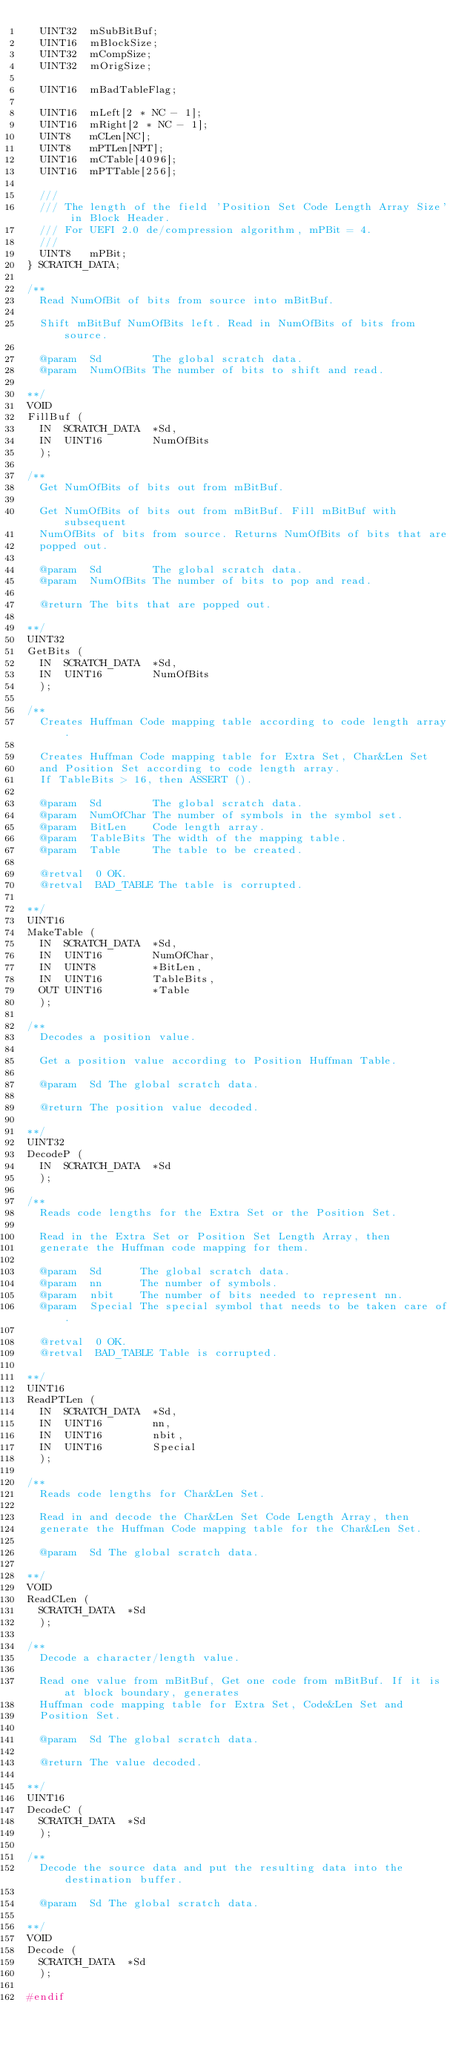<code> <loc_0><loc_0><loc_500><loc_500><_C_>  UINT32  mSubBitBuf;
  UINT16  mBlockSize;
  UINT32  mCompSize;
  UINT32  mOrigSize;

  UINT16  mBadTableFlag;

  UINT16  mLeft[2 * NC - 1];
  UINT16  mRight[2 * NC - 1];
  UINT8   mCLen[NC];
  UINT8   mPTLen[NPT];
  UINT16  mCTable[4096];
  UINT16  mPTTable[256];

  ///
  /// The length of the field 'Position Set Code Length Array Size' in Block Header.
  /// For UEFI 2.0 de/compression algorithm, mPBit = 4.
  ///
  UINT8   mPBit;
} SCRATCH_DATA;

/**
  Read NumOfBit of bits from source into mBitBuf.

  Shift mBitBuf NumOfBits left. Read in NumOfBits of bits from source.

  @param  Sd        The global scratch data.
  @param  NumOfBits The number of bits to shift and read.

**/
VOID
FillBuf (
  IN  SCRATCH_DATA  *Sd,
  IN  UINT16        NumOfBits
  );

/**
  Get NumOfBits of bits out from mBitBuf.

  Get NumOfBits of bits out from mBitBuf. Fill mBitBuf with subsequent
  NumOfBits of bits from source. Returns NumOfBits of bits that are
  popped out.

  @param  Sd        The global scratch data.
  @param  NumOfBits The number of bits to pop and read.

  @return The bits that are popped out.

**/
UINT32
GetBits (
  IN  SCRATCH_DATA  *Sd,
  IN  UINT16        NumOfBits
  );

/**
  Creates Huffman Code mapping table according to code length array.

  Creates Huffman Code mapping table for Extra Set, Char&Len Set
  and Position Set according to code length array.
  If TableBits > 16, then ASSERT ().

  @param  Sd        The global scratch data.
  @param  NumOfChar The number of symbols in the symbol set.
  @param  BitLen    Code length array.
  @param  TableBits The width of the mapping table.
  @param  Table     The table to be created.

  @retval  0 OK.
  @retval  BAD_TABLE The table is corrupted.

**/
UINT16
MakeTable (
  IN  SCRATCH_DATA  *Sd,
  IN  UINT16        NumOfChar,
  IN  UINT8         *BitLen,
  IN  UINT16        TableBits,
  OUT UINT16        *Table
  );

/**
  Decodes a position value.

  Get a position value according to Position Huffman Table.

  @param  Sd The global scratch data.

  @return The position value decoded.

**/
UINT32
DecodeP (
  IN  SCRATCH_DATA  *Sd
  );

/**
  Reads code lengths for the Extra Set or the Position Set.

  Read in the Extra Set or Position Set Length Array, then
  generate the Huffman code mapping for them.

  @param  Sd      The global scratch data.
  @param  nn      The number of symbols.
  @param  nbit    The number of bits needed to represent nn.
  @param  Special The special symbol that needs to be taken care of.

  @retval  0 OK.
  @retval  BAD_TABLE Table is corrupted.

**/
UINT16
ReadPTLen (
  IN  SCRATCH_DATA  *Sd,
  IN  UINT16        nn,
  IN  UINT16        nbit,
  IN  UINT16        Special
  );

/**
  Reads code lengths for Char&Len Set.

  Read in and decode the Char&Len Set Code Length Array, then
  generate the Huffman Code mapping table for the Char&Len Set.

  @param  Sd The global scratch data.

**/
VOID
ReadCLen (
  SCRATCH_DATA  *Sd
  );

/**
  Decode a character/length value.

  Read one value from mBitBuf, Get one code from mBitBuf. If it is at block boundary, generates
  Huffman code mapping table for Extra Set, Code&Len Set and
  Position Set.

  @param  Sd The global scratch data.

  @return The value decoded.

**/
UINT16
DecodeC (
  SCRATCH_DATA  *Sd
  );

/**
  Decode the source data and put the resulting data into the destination buffer.

  @param  Sd The global scratch data.

**/
VOID
Decode (
  SCRATCH_DATA  *Sd
  );

#endif
</code> 